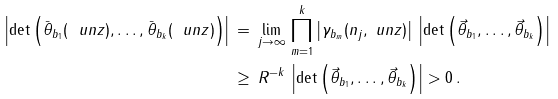Convert formula to latex. <formula><loc_0><loc_0><loc_500><loc_500>\left | \det \left ( \bar { \theta } _ { b _ { 1 } } ( \ u n { z } ) , \dots , \bar { \theta } _ { b _ { k } } ( \ u n { z } ) \right ) \right | \, & = \, \lim _ { j \to \infty } \, \prod _ { m = 1 } ^ { k } \left | \gamma _ { b _ { m } } ( n _ { j } , \ u n { z } ) \right | \, \left | \det \left ( \vec { \theta } _ { b _ { 1 } } , \dots , \vec { \theta } _ { b _ { k } } \right ) \right | \\ \, & \geq \, R ^ { - k } \, \left | \det \left ( \vec { \theta } _ { b _ { 1 } } , \dots , \vec { \theta } _ { b _ { k } } \right ) \right | > 0 \, .</formula> 